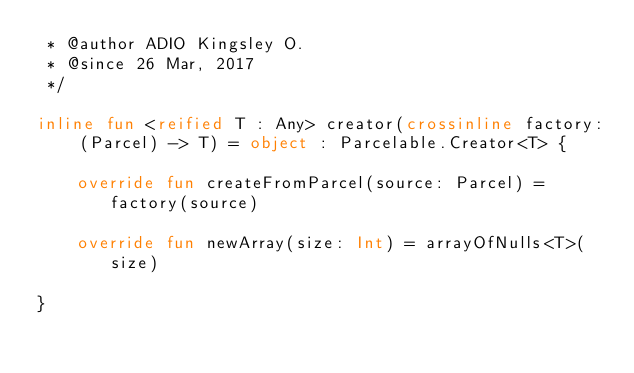<code> <loc_0><loc_0><loc_500><loc_500><_Kotlin_> * @author ADIO Kingsley O.
 * @since 26 Mar, 2017
 */

inline fun <reified T : Any> creator(crossinline factory: (Parcel) -> T) = object : Parcelable.Creator<T> {

    override fun createFromParcel(source: Parcel) = factory(source)

    override fun newArray(size: Int) = arrayOfNulls<T>(size)

}
</code> 